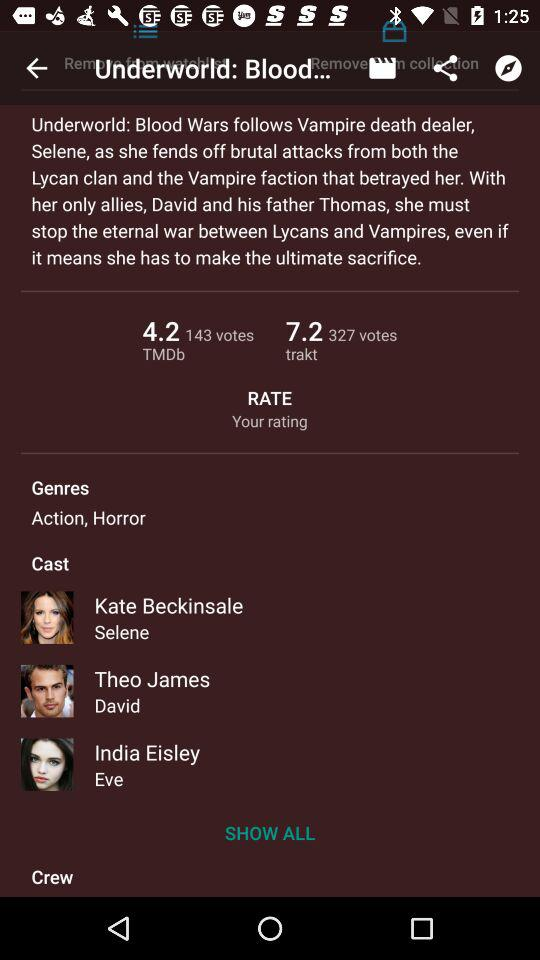What are the genres of the movie? The genres of the movie are Action and Horror. 